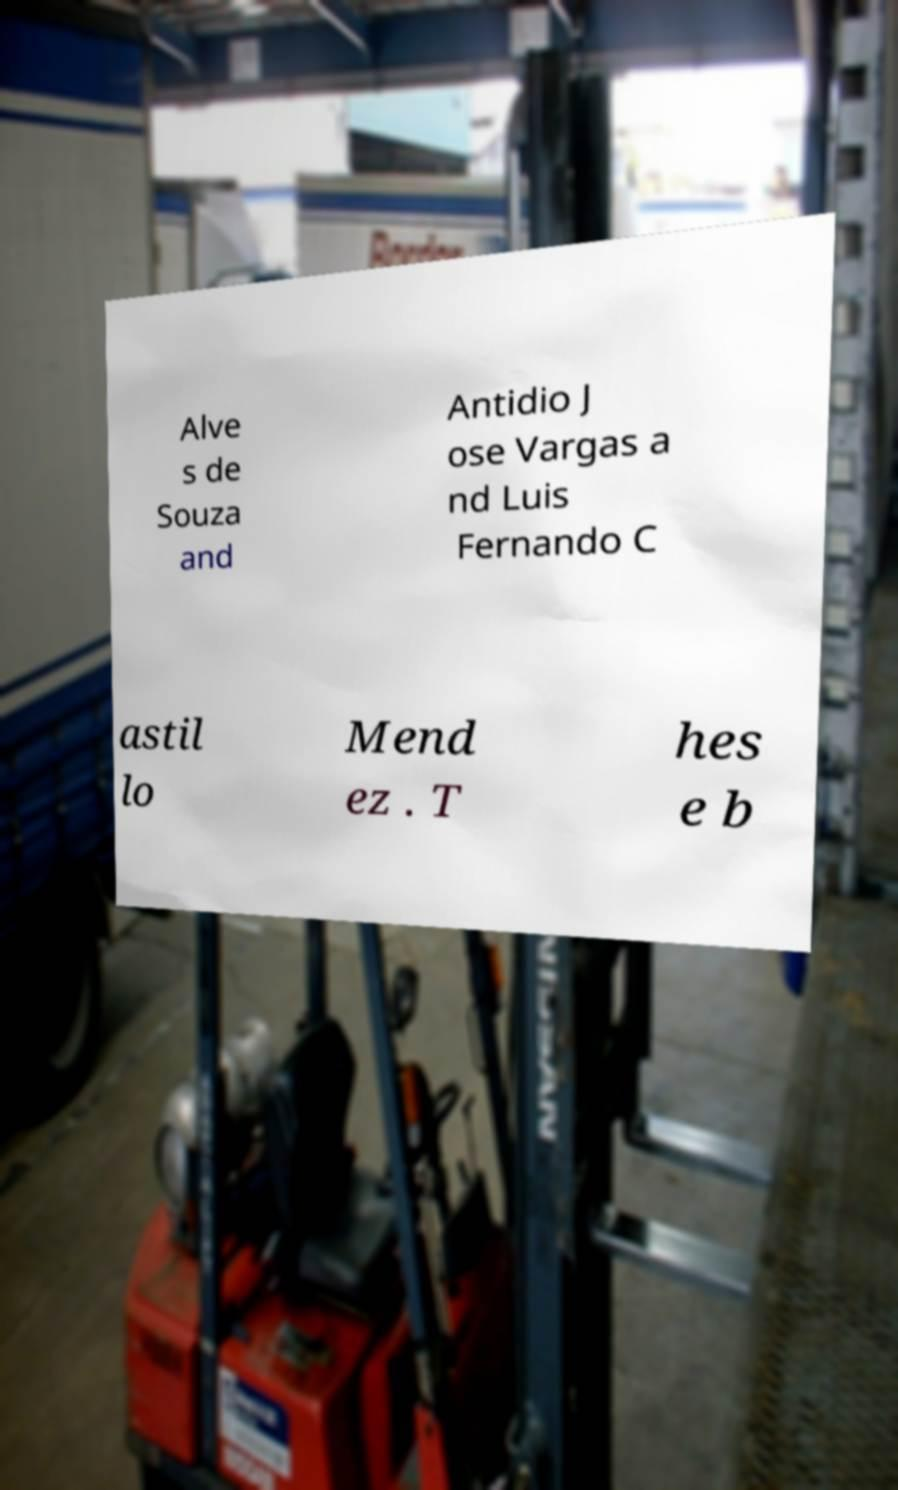Can you read and provide the text displayed in the image?This photo seems to have some interesting text. Can you extract and type it out for me? Alve s de Souza and Antidio J ose Vargas a nd Luis Fernando C astil lo Mend ez . T hes e b 